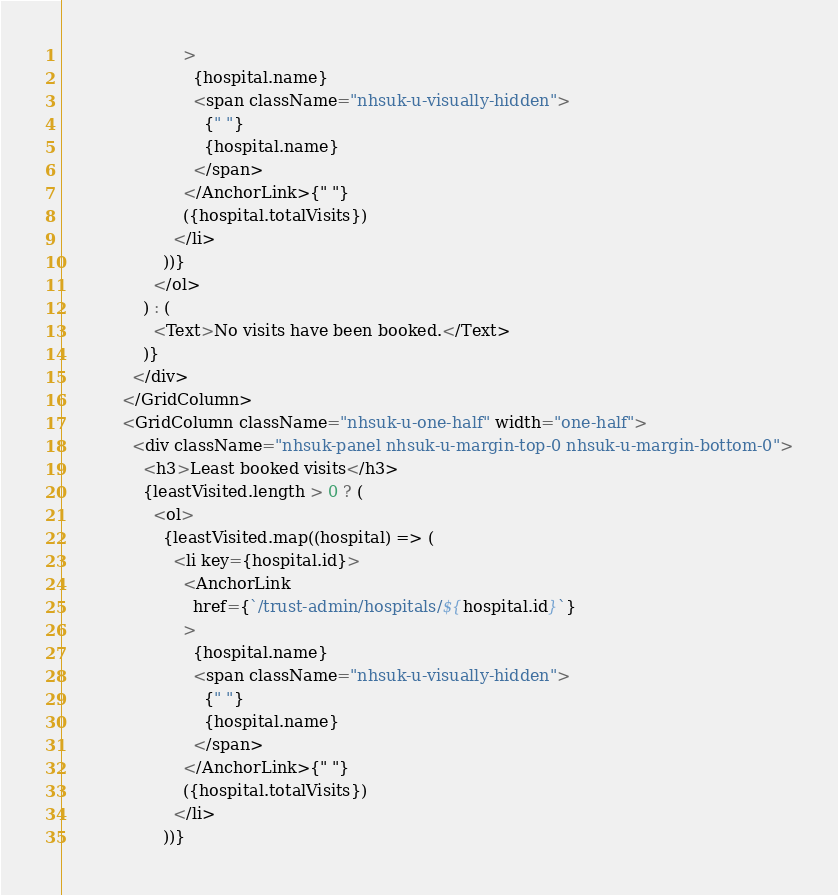<code> <loc_0><loc_0><loc_500><loc_500><_JavaScript_>                        >
                          {hospital.name}
                          <span className="nhsuk-u-visually-hidden">
                            {" "}
                            {hospital.name}
                          </span>
                        </AnchorLink>{" "}
                        ({hospital.totalVisits})
                      </li>
                    ))}
                  </ol>
                ) : (
                  <Text>No visits have been booked.</Text>
                )}
              </div>
            </GridColumn>
            <GridColumn className="nhsuk-u-one-half" width="one-half">
              <div className="nhsuk-panel nhsuk-u-margin-top-0 nhsuk-u-margin-bottom-0">
                <h3>Least booked visits</h3>
                {leastVisited.length > 0 ? (
                  <ol>
                    {leastVisited.map((hospital) => (
                      <li key={hospital.id}>
                        <AnchorLink
                          href={`/trust-admin/hospitals/${hospital.id}`}
                        >
                          {hospital.name}
                          <span className="nhsuk-u-visually-hidden">
                            {" "}
                            {hospital.name}
                          </span>
                        </AnchorLink>{" "}
                        ({hospital.totalVisits})
                      </li>
                    ))}</code> 